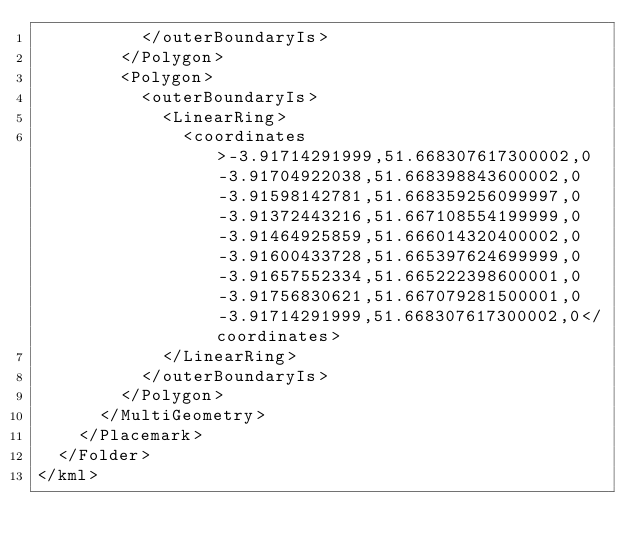<code> <loc_0><loc_0><loc_500><loc_500><_XML_>          </outerBoundaryIs>
        </Polygon>
        <Polygon>
          <outerBoundaryIs>
            <LinearRing>
              <coordinates>-3.91714291999,51.668307617300002,0 -3.91704922038,51.668398843600002,0 -3.91598142781,51.668359256099997,0 -3.91372443216,51.667108554199999,0 -3.91464925859,51.666014320400002,0 -3.91600433728,51.665397624699999,0 -3.91657552334,51.665222398600001,0 -3.91756830621,51.667079281500001,0 -3.91714291999,51.668307617300002,0</coordinates>
            </LinearRing>
          </outerBoundaryIs>
        </Polygon>
      </MultiGeometry>
    </Placemark>
  </Folder>
</kml>
</code> 